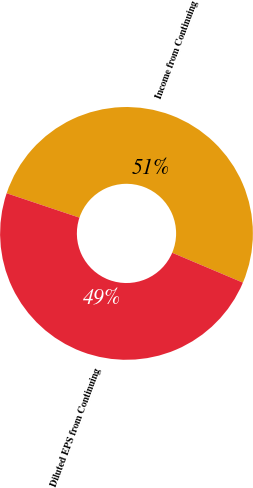Convert chart. <chart><loc_0><loc_0><loc_500><loc_500><pie_chart><fcel>Income from Continuing<fcel>Diluted EPS from Continuing<nl><fcel>51.22%<fcel>48.78%<nl></chart> 